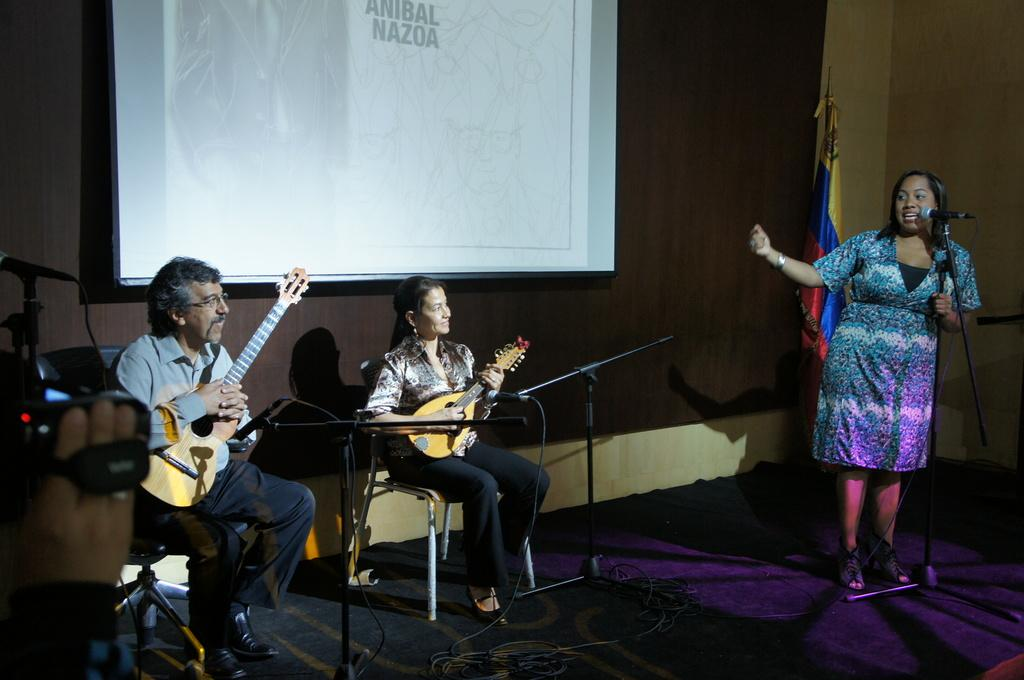How many people are in the image? There are two women and a man in the image. What is one of the women doing in the image? One woman is standing and singing in front of a microphone. What are the other two people holding in the background? A woman and a man are holding a guitar in the background. What piece of equipment can be seen in the background? There is a projector visible in the background. What type of bird can be seen flying in the image? There is no bird visible in the image. Can you tell me the route the tiger is taking in the image? There is no tiger present in the image. 